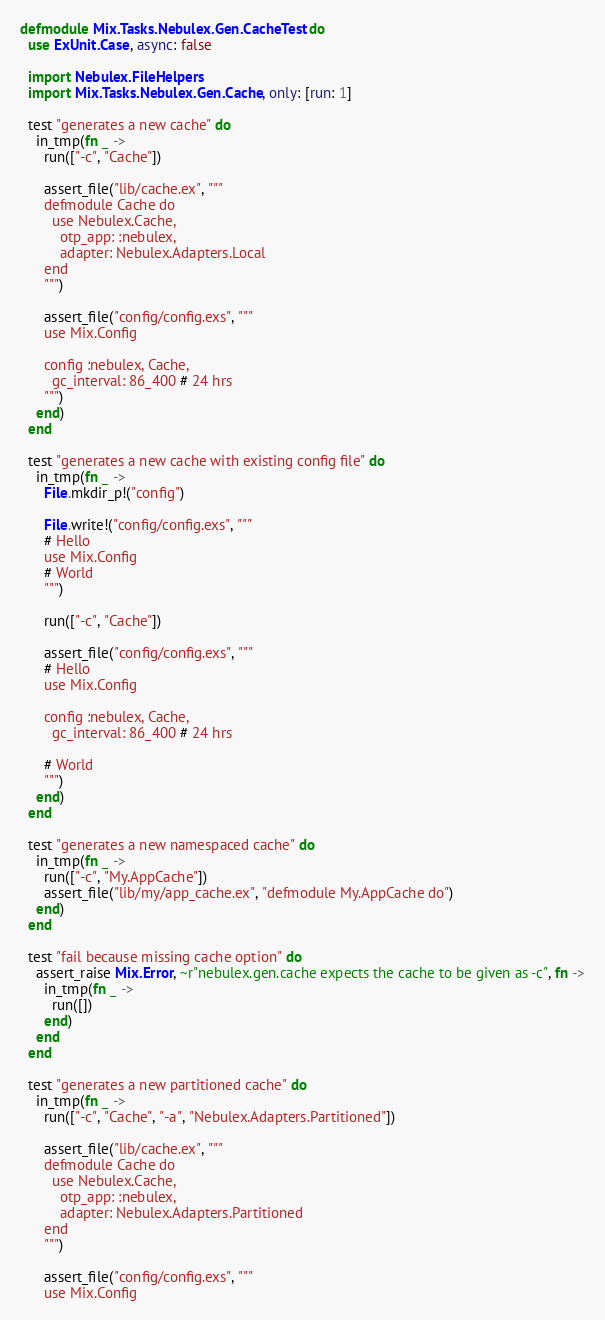<code> <loc_0><loc_0><loc_500><loc_500><_Elixir_>defmodule Mix.Tasks.Nebulex.Gen.CacheTest do
  use ExUnit.Case, async: false

  import Nebulex.FileHelpers
  import Mix.Tasks.Nebulex.Gen.Cache, only: [run: 1]

  test "generates a new cache" do
    in_tmp(fn _ ->
      run(["-c", "Cache"])

      assert_file("lib/cache.ex", """
      defmodule Cache do
        use Nebulex.Cache,
          otp_app: :nebulex,
          adapter: Nebulex.Adapters.Local
      end
      """)

      assert_file("config/config.exs", """
      use Mix.Config

      config :nebulex, Cache,
        gc_interval: 86_400 # 24 hrs
      """)
    end)
  end

  test "generates a new cache with existing config file" do
    in_tmp(fn _ ->
      File.mkdir_p!("config")

      File.write!("config/config.exs", """
      # Hello
      use Mix.Config
      # World
      """)

      run(["-c", "Cache"])

      assert_file("config/config.exs", """
      # Hello
      use Mix.Config

      config :nebulex, Cache,
        gc_interval: 86_400 # 24 hrs

      # World
      """)
    end)
  end

  test "generates a new namespaced cache" do
    in_tmp(fn _ ->
      run(["-c", "My.AppCache"])
      assert_file("lib/my/app_cache.ex", "defmodule My.AppCache do")
    end)
  end

  test "fail because missing cache option" do
    assert_raise Mix.Error, ~r"nebulex.gen.cache expects the cache to be given as -c", fn ->
      in_tmp(fn _ ->
        run([])
      end)
    end
  end

  test "generates a new partitioned cache" do
    in_tmp(fn _ ->
      run(["-c", "Cache", "-a", "Nebulex.Adapters.Partitioned"])

      assert_file("lib/cache.ex", """
      defmodule Cache do
        use Nebulex.Cache,
          otp_app: :nebulex,
          adapter: Nebulex.Adapters.Partitioned
      end
      """)

      assert_file("config/config.exs", """
      use Mix.Config
</code> 